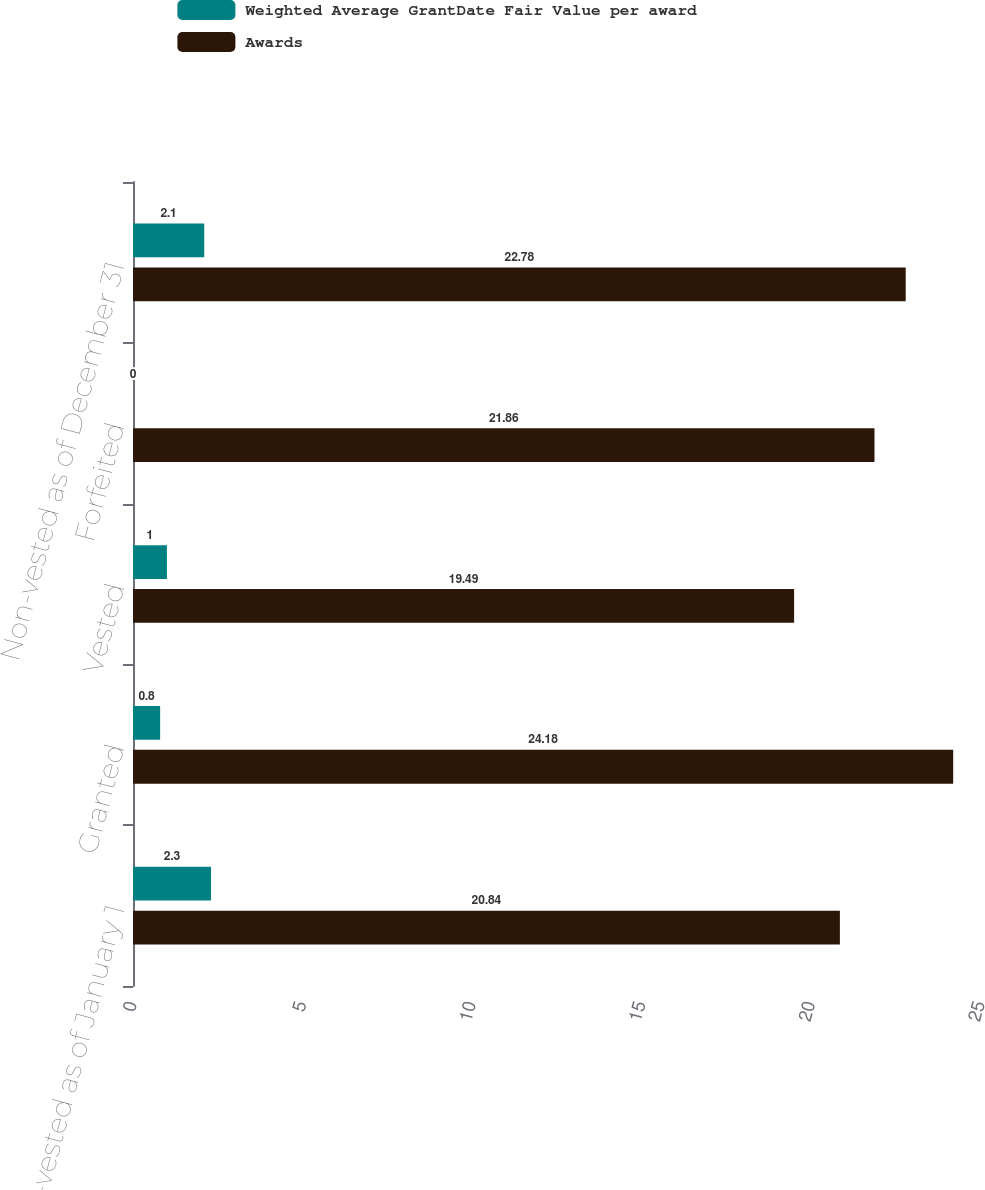Convert chart. <chart><loc_0><loc_0><loc_500><loc_500><stacked_bar_chart><ecel><fcel>Non-vested as of January 1<fcel>Granted<fcel>Vested<fcel>Forfeited<fcel>Non-vested as of December 31<nl><fcel>Weighted Average GrantDate Fair Value per award<fcel>2.3<fcel>0.8<fcel>1<fcel>0<fcel>2.1<nl><fcel>Awards<fcel>20.84<fcel>24.18<fcel>19.49<fcel>21.86<fcel>22.78<nl></chart> 